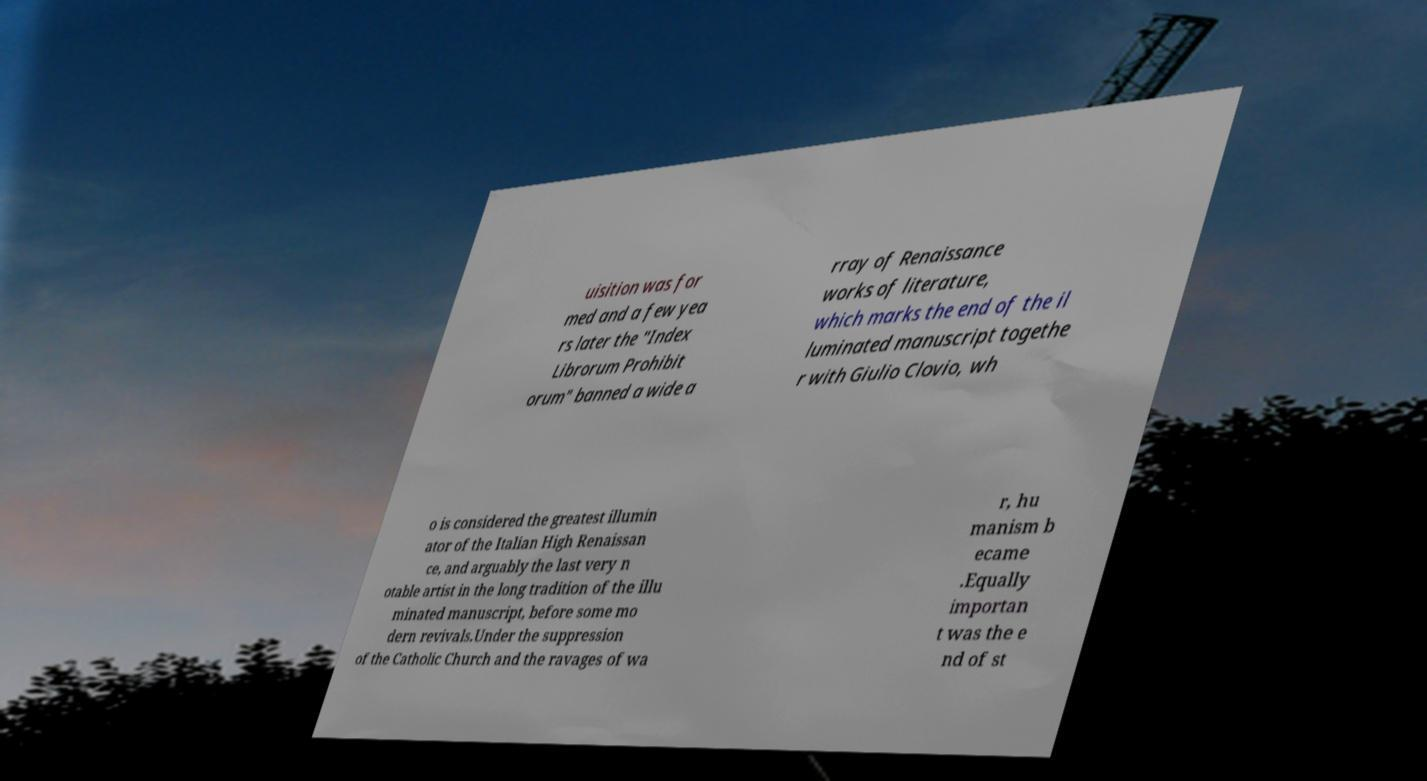Please identify and transcribe the text found in this image. uisition was for med and a few yea rs later the "Index Librorum Prohibit orum" banned a wide a rray of Renaissance works of literature, which marks the end of the il luminated manuscript togethe r with Giulio Clovio, wh o is considered the greatest illumin ator of the Italian High Renaissan ce, and arguably the last very n otable artist in the long tradition of the illu minated manuscript, before some mo dern revivals.Under the suppression of the Catholic Church and the ravages of wa r, hu manism b ecame .Equally importan t was the e nd of st 